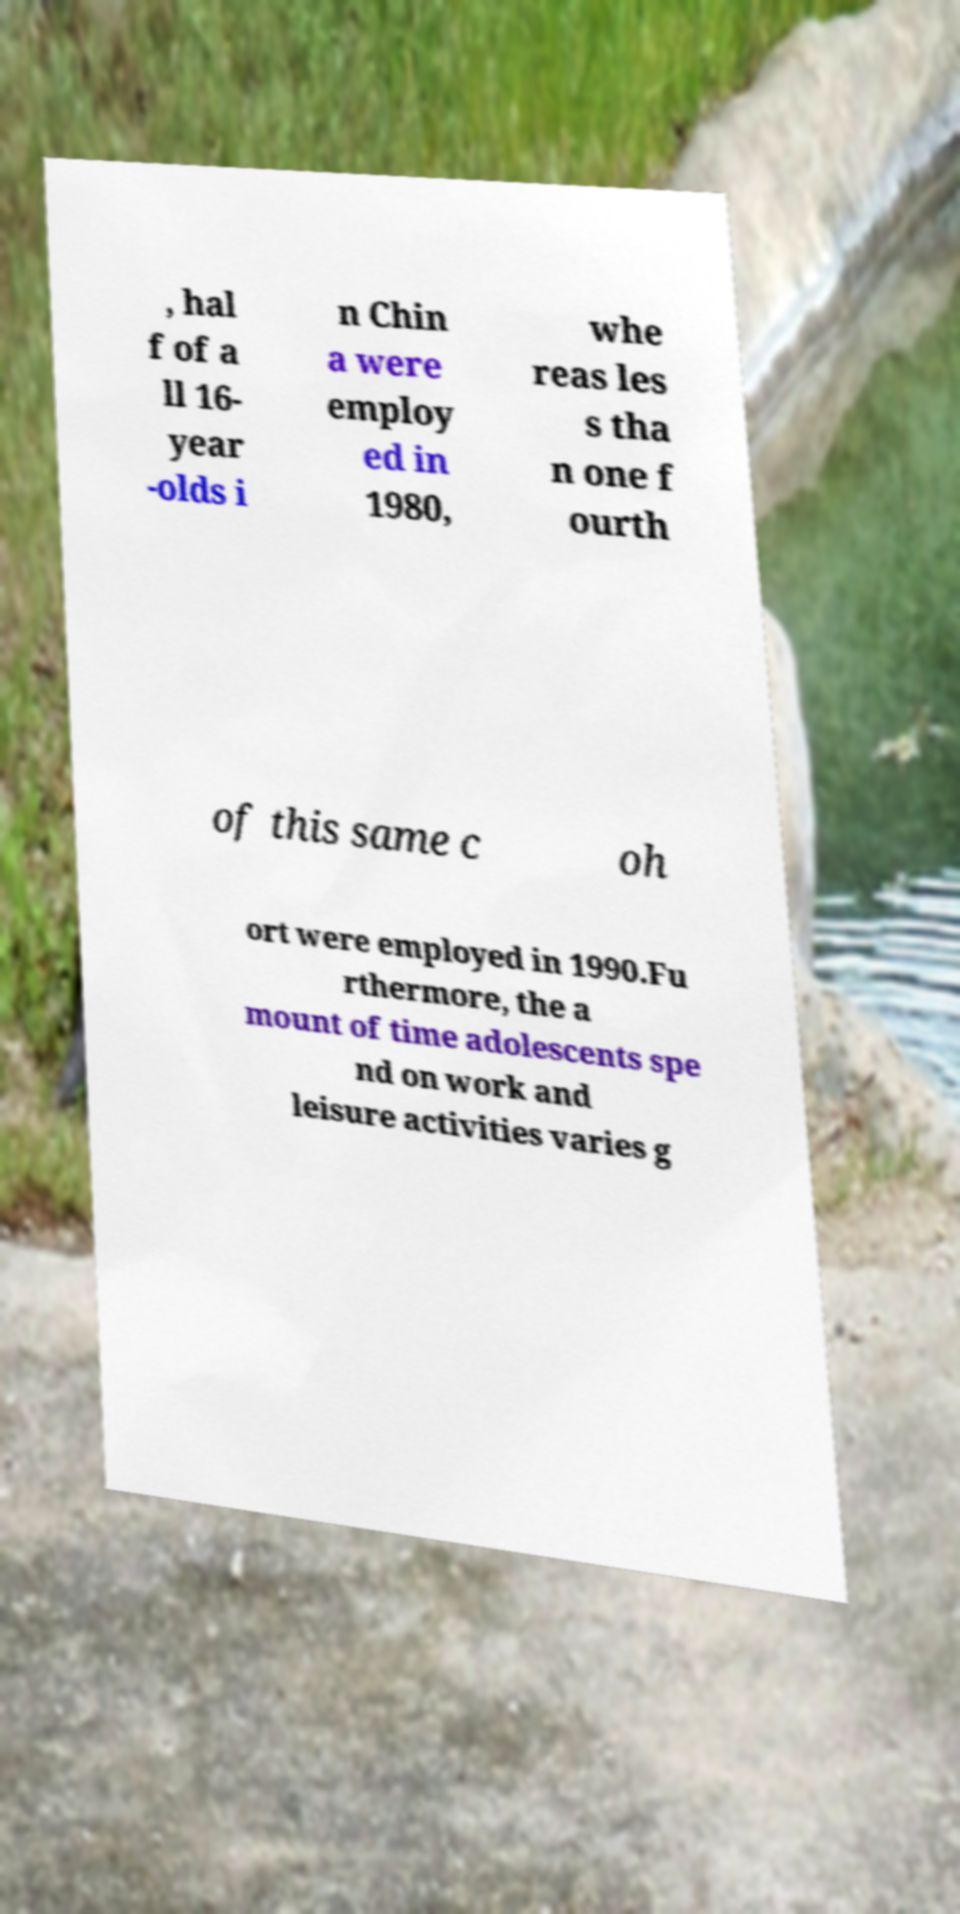Could you extract and type out the text from this image? , hal f of a ll 16- year -olds i n Chin a were employ ed in 1980, whe reas les s tha n one f ourth of this same c oh ort were employed in 1990.Fu rthermore, the a mount of time adolescents spe nd on work and leisure activities varies g 